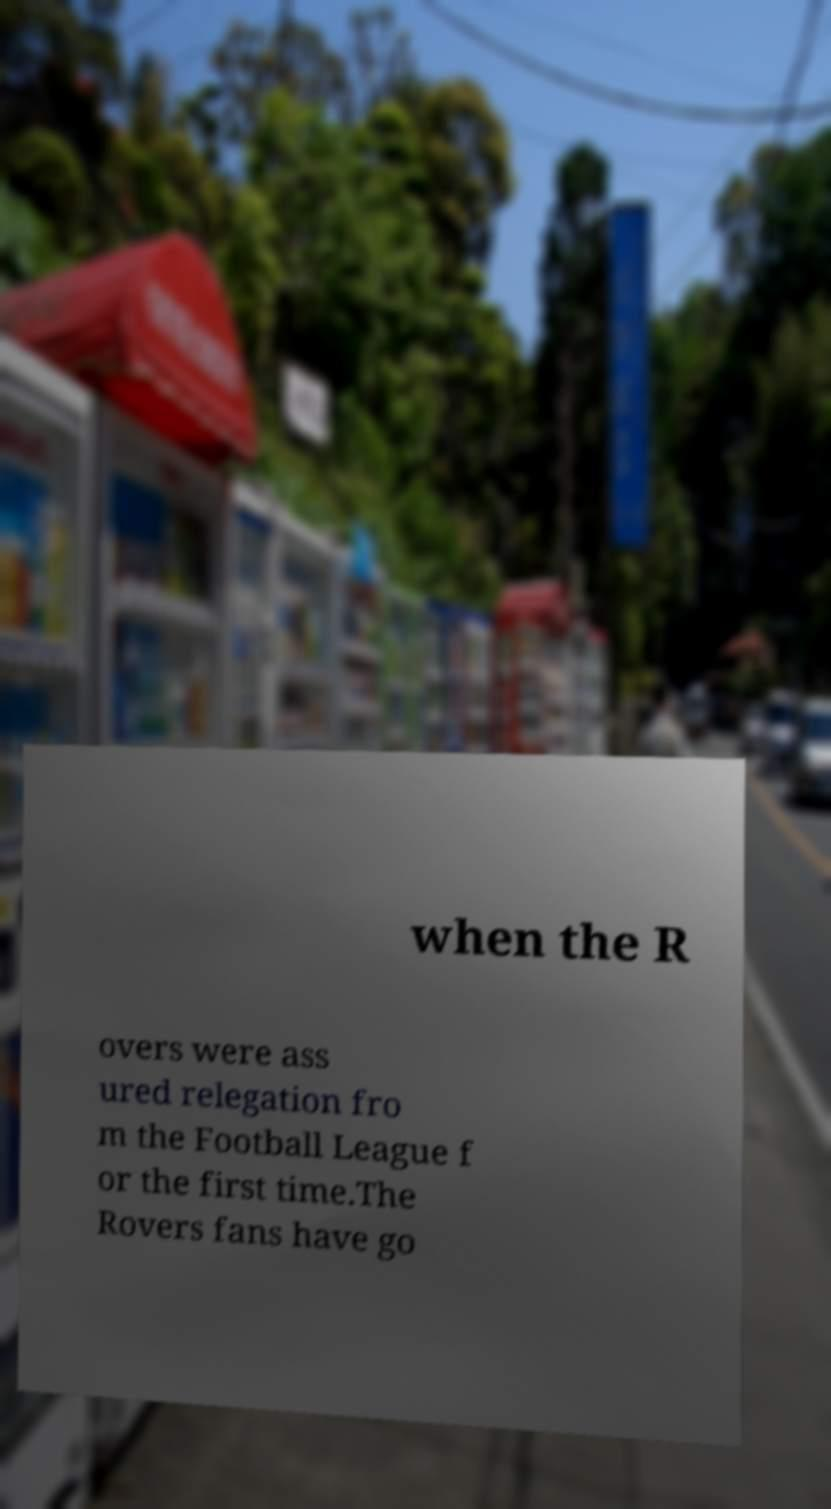For documentation purposes, I need the text within this image transcribed. Could you provide that? when the R overs were ass ured relegation fro m the Football League f or the first time.The Rovers fans have go 